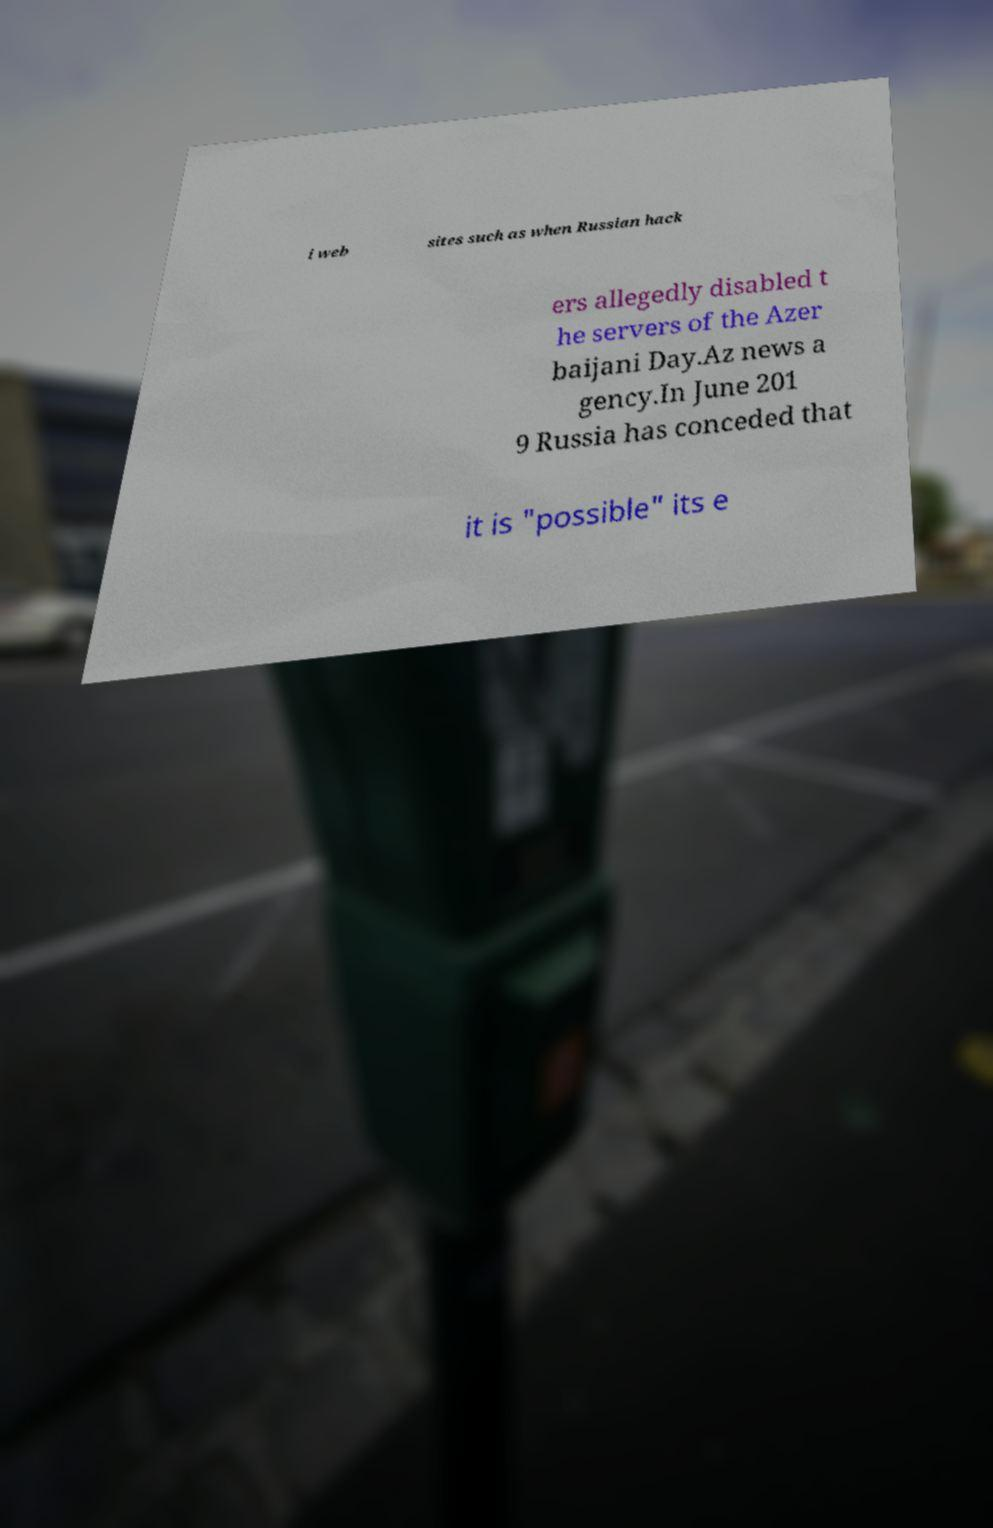For documentation purposes, I need the text within this image transcribed. Could you provide that? i web sites such as when Russian hack ers allegedly disabled t he servers of the Azer baijani Day.Az news a gency.In June 201 9 Russia has conceded that it is "possible" its e 